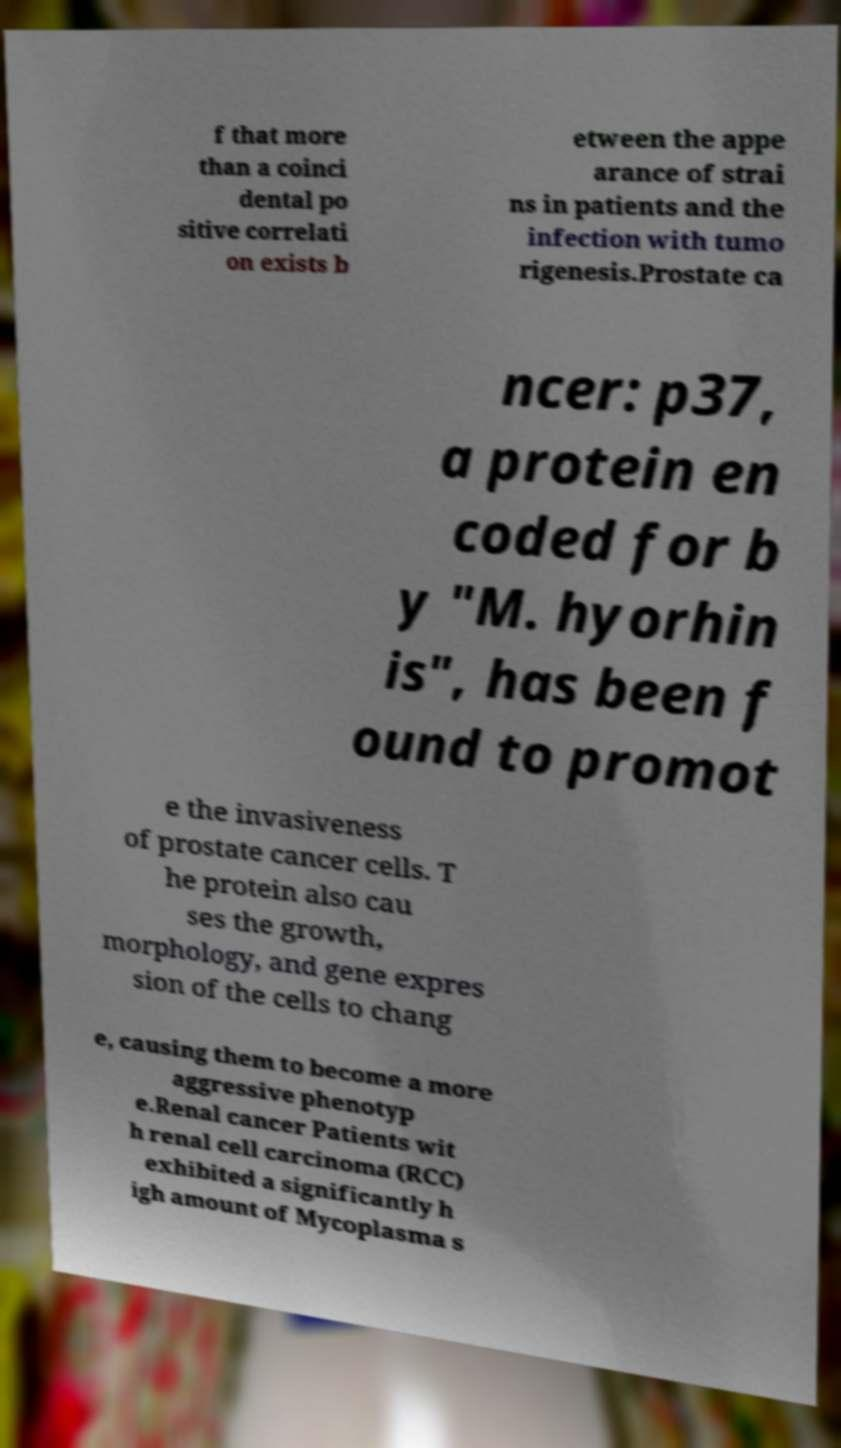What messages or text are displayed in this image? I need them in a readable, typed format. f that more than a coinci dental po sitive correlati on exists b etween the appe arance of strai ns in patients and the infection with tumo rigenesis.Prostate ca ncer: p37, a protein en coded for b y "M. hyorhin is", has been f ound to promot e the invasiveness of prostate cancer cells. T he protein also cau ses the growth, morphology, and gene expres sion of the cells to chang e, causing them to become a more aggressive phenotyp e.Renal cancer Patients wit h renal cell carcinoma (RCC) exhibited a significantly h igh amount of Mycoplasma s 